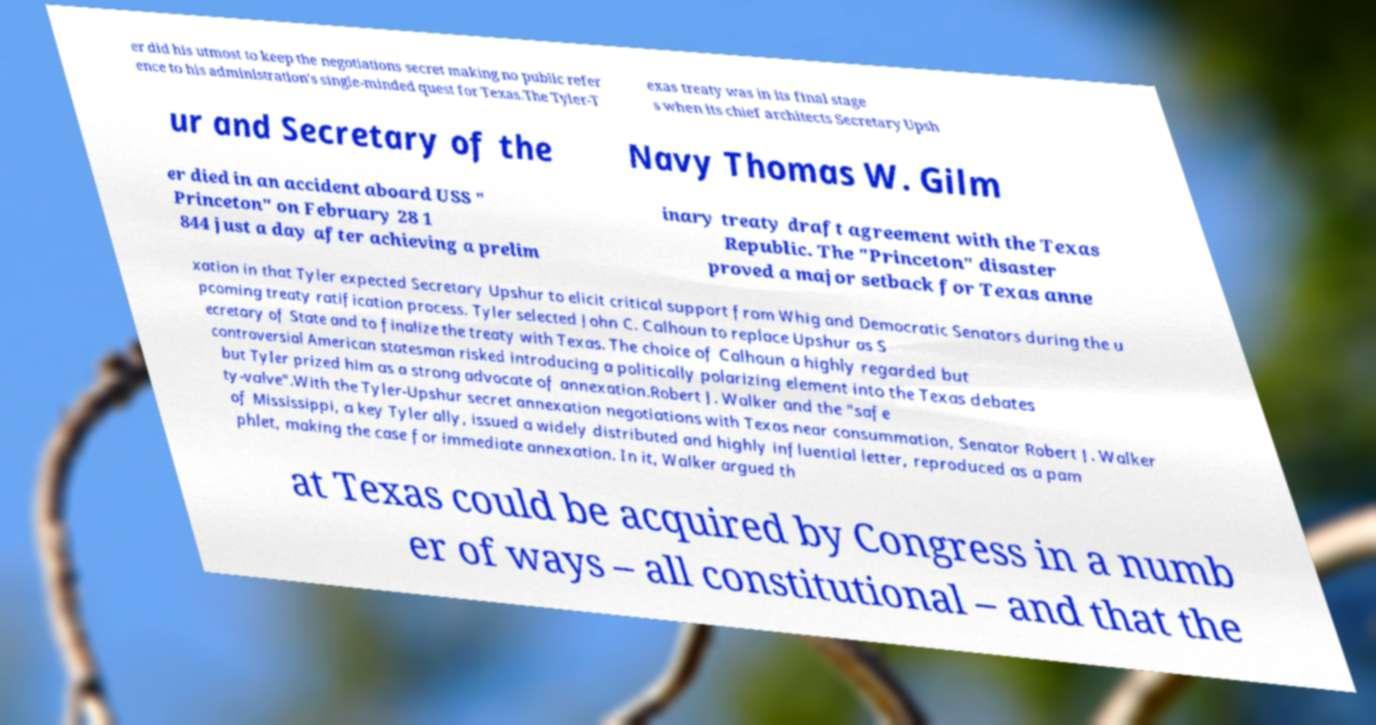For documentation purposes, I need the text within this image transcribed. Could you provide that? er did his utmost to keep the negotiations secret making no public refer ence to his administration's single-minded quest for Texas.The Tyler-T exas treaty was in its final stage s when its chief architects Secretary Upsh ur and Secretary of the Navy Thomas W. Gilm er died in an accident aboard USS " Princeton" on February 28 1 844 just a day after achieving a prelim inary treaty draft agreement with the Texas Republic. The "Princeton" disaster proved a major setback for Texas anne xation in that Tyler expected Secretary Upshur to elicit critical support from Whig and Democratic Senators during the u pcoming treaty ratification process. Tyler selected John C. Calhoun to replace Upshur as S ecretary of State and to finalize the treaty with Texas. The choice of Calhoun a highly regarded but controversial American statesman risked introducing a politically polarizing element into the Texas debates but Tyler prized him as a strong advocate of annexation.Robert J. Walker and the "safe ty-valve".With the Tyler-Upshur secret annexation negotiations with Texas near consummation, Senator Robert J. Walker of Mississippi, a key Tyler ally, issued a widely distributed and highly influential letter, reproduced as a pam phlet, making the case for immediate annexation. In it, Walker argued th at Texas could be acquired by Congress in a numb er of ways – all constitutional – and that the 